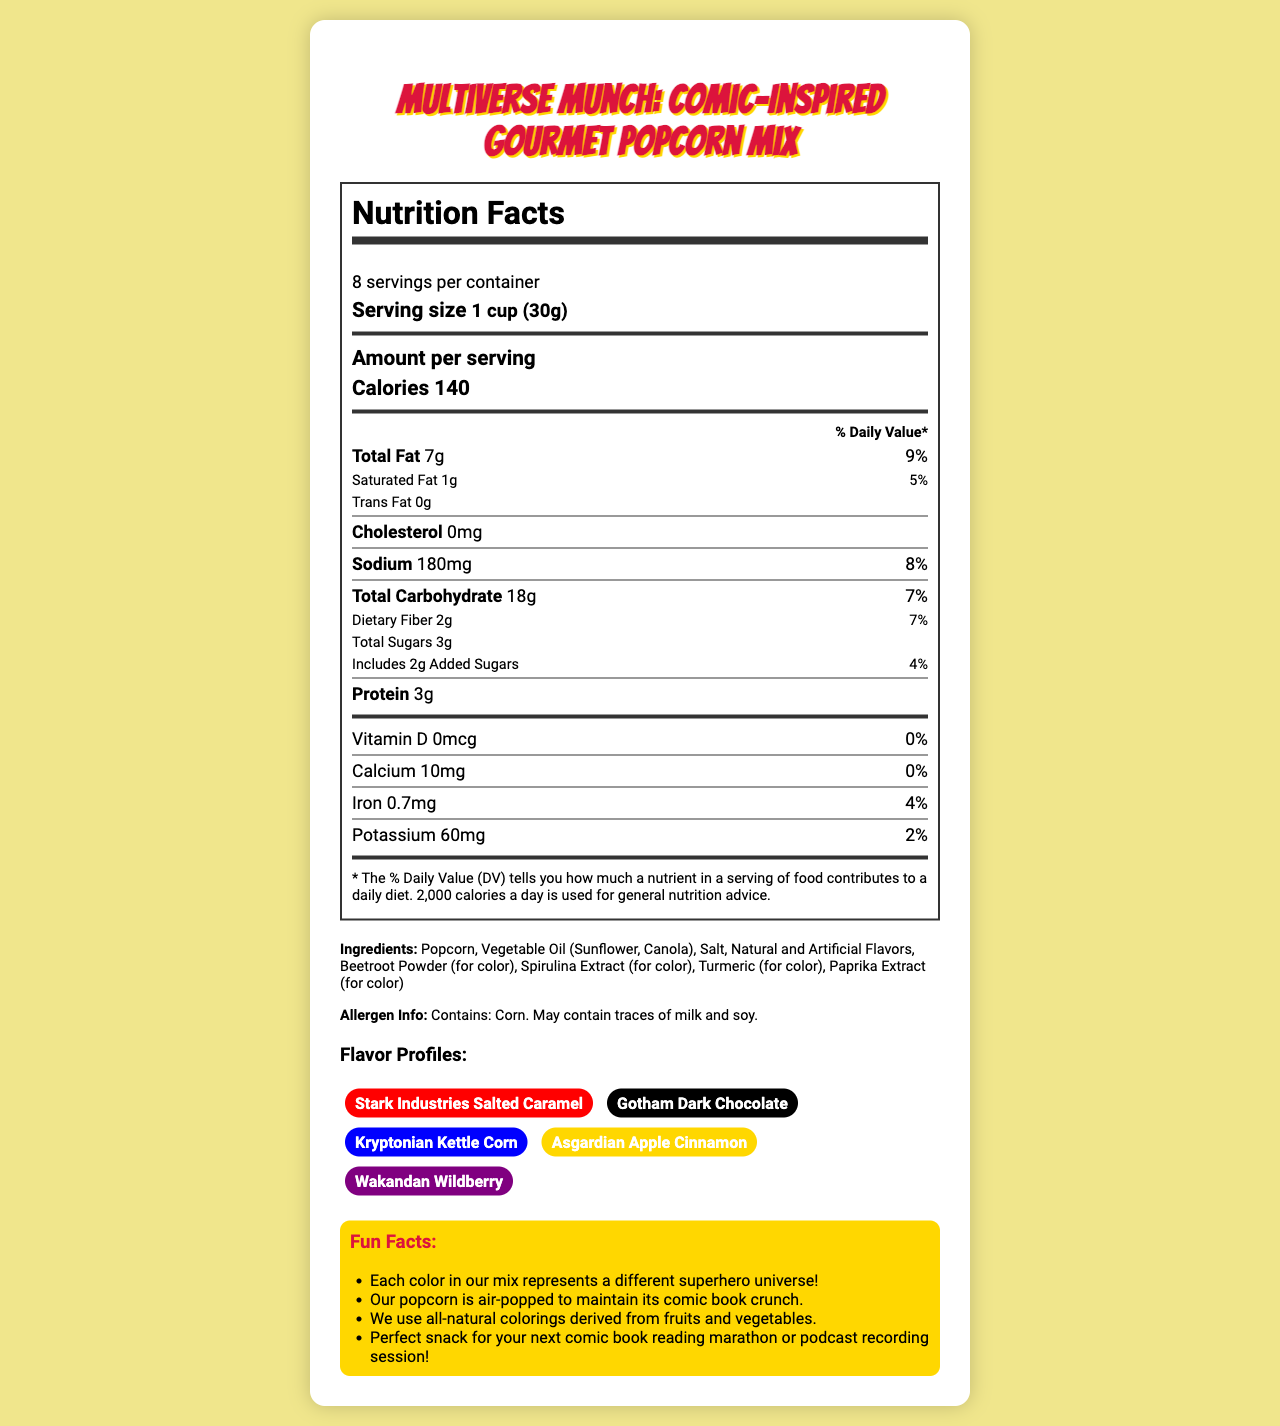what is the serving size of Multiverse Munch? The serving size is explicitly mentioned under the header "Serving size".
Answer: 1 cup (30g) how many servings are in each container? It is stated that there are 8 servings per container under the "Nutrition Facts" section.
Answer: 8 how many calories are in one serving? The calorie count per serving is directly mentioned under "Calories" in the nutrition label.
Answer: 140 which flavor profile is inspired by Iron Man? The list of flavor profiles states that Stark Industries Salted Caramel is inspired by Iron Man.
Answer: Stark Industries Salted Caramel does the product contain any trans fat? The label shows "Trans Fat 0g," which indicates there is no trans fat.
Answer: No what ingredient is used for making the red color? Under the list of ingredients, it mentions Beetroot Powder is used for color, which is commonly red.
Answer: Beetroot Powder how much protein is in one serving? The nutrition label lists 3g of protein per serving.
Answer: 3g what is the amount of sodium per serving? The sodium content per serving is specified as 180mg in the nutrition label.
Answer: 180mg how much added sugar is present in one serving? The nutrition label specifies 2g of added sugars per serving.
Answer: 2g which flavor is gold in color and inspired by Thor? The flavor profiles list Asgardian Apple Cinnamon as gold in color and inspired by Thor.
Answer: Asgardian Apple Cinnamon which pairing is recommended for the episode "Exploring Wakanda: The World of Black Panther"? A. Stark Industries Salted Caramel B. Gotham Dark Chocolate C. Wakandan Wildberry D. Kryptonian Kettle Corn The document lists that the podcast episode "Exploring Wakanda: The World of Black Panther" pairs with Wakandan Wildberry.
Answer: C how much iron is in one serving? The amount of iron per serving is clearly stated as 0.7mg in the nutrition label.
Answer: 0.7mg which nutrient has the highest daily value percentage in one serving? A. Total Fat B. Vitamin D C. Sodium D. Dietary Fiber Total Fat at 9% daily value is the highest among the listed nutrients.
Answer: A are there any traces of milk and soy in the product? The allergen information states that the product may contain traces of milk and soy.
Answer: Yes summarize the main idea of the document. The main idea involves various aspects of the product: its nutritional content, ingredients, flavors inspired by different comic book characters, and fun additions like podcast pairings and interesting facts.
Answer: The document provides the nutritional information, ingredients list, allergen info, flavor profiles, podcast pairings, and fun facts about Multiverse Munch, a comic-inspired gourmet popcorn mix. what flavor could be paired with "The Dark Knight Returns: A Frank Miller Masterpiece"? The document does not provide a specific flavor suitable for this episode.
Answer: Cannot be determined how much calcium is there in one serving? The nutrition label indicates that there are 10mg of calcium per serving.
Answer: 10mg does this product include any artificial flavors? The ingredients list includes "Natural and Artificial Flavors," indicating the presence of artificial flavors.
Answer: Yes 